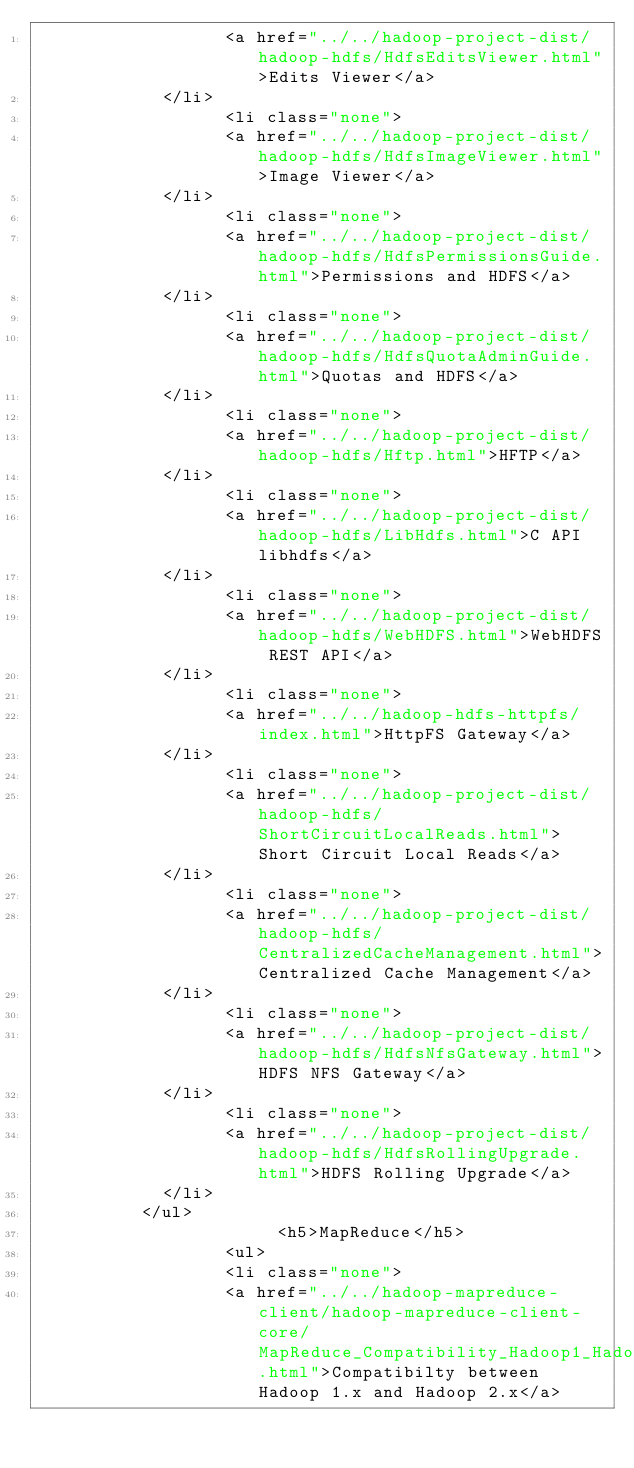<code> <loc_0><loc_0><loc_500><loc_500><_HTML_>                  <a href="../../hadoop-project-dist/hadoop-hdfs/HdfsEditsViewer.html">Edits Viewer</a>
            </li>
                  <li class="none">
                  <a href="../../hadoop-project-dist/hadoop-hdfs/HdfsImageViewer.html">Image Viewer</a>
            </li>
                  <li class="none">
                  <a href="../../hadoop-project-dist/hadoop-hdfs/HdfsPermissionsGuide.html">Permissions and HDFS</a>
            </li>
                  <li class="none">
                  <a href="../../hadoop-project-dist/hadoop-hdfs/HdfsQuotaAdminGuide.html">Quotas and HDFS</a>
            </li>
                  <li class="none">
                  <a href="../../hadoop-project-dist/hadoop-hdfs/Hftp.html">HFTP</a>
            </li>
                  <li class="none">
                  <a href="../../hadoop-project-dist/hadoop-hdfs/LibHdfs.html">C API libhdfs</a>
            </li>
                  <li class="none">
                  <a href="../../hadoop-project-dist/hadoop-hdfs/WebHDFS.html">WebHDFS REST API</a>
            </li>
                  <li class="none">
                  <a href="../../hadoop-hdfs-httpfs/index.html">HttpFS Gateway</a>
            </li>
                  <li class="none">
                  <a href="../../hadoop-project-dist/hadoop-hdfs/ShortCircuitLocalReads.html">Short Circuit Local Reads</a>
            </li>
                  <li class="none">
                  <a href="../../hadoop-project-dist/hadoop-hdfs/CentralizedCacheManagement.html">Centralized Cache Management</a>
            </li>
                  <li class="none">
                  <a href="../../hadoop-project-dist/hadoop-hdfs/HdfsNfsGateway.html">HDFS NFS Gateway</a>
            </li>
                  <li class="none">
                  <a href="../../hadoop-project-dist/hadoop-hdfs/HdfsRollingUpgrade.html">HDFS Rolling Upgrade</a>
            </li>
          </ul>
                       <h5>MapReduce</h5>
                  <ul>
                  <li class="none">
                  <a href="../../hadoop-mapreduce-client/hadoop-mapreduce-client-core/MapReduce_Compatibility_Hadoop1_Hadoop2.html">Compatibilty between Hadoop 1.x and Hadoop 2.x</a></code> 